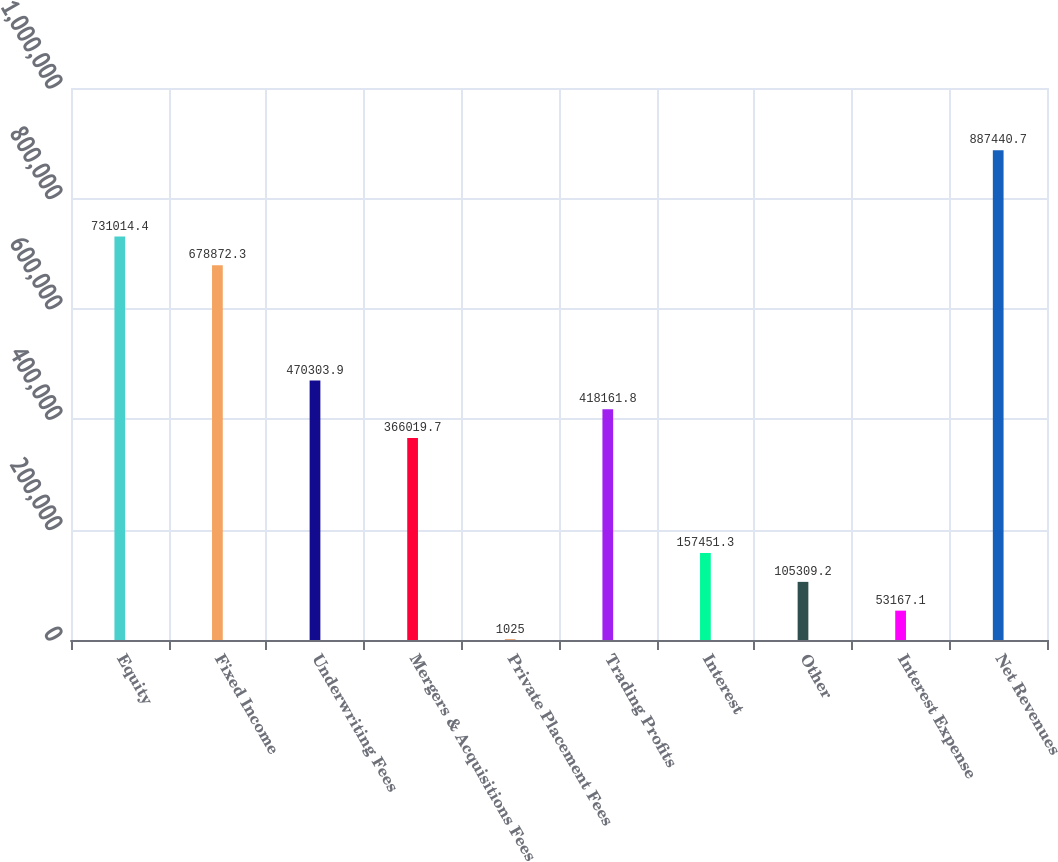<chart> <loc_0><loc_0><loc_500><loc_500><bar_chart><fcel>Equity<fcel>Fixed Income<fcel>Underwriting Fees<fcel>Mergers & Acquisitions Fees<fcel>Private Placement Fees<fcel>Trading Profits<fcel>Interest<fcel>Other<fcel>Interest Expense<fcel>Net Revenues<nl><fcel>731014<fcel>678872<fcel>470304<fcel>366020<fcel>1025<fcel>418162<fcel>157451<fcel>105309<fcel>53167.1<fcel>887441<nl></chart> 